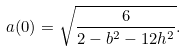Convert formula to latex. <formula><loc_0><loc_0><loc_500><loc_500>a ( 0 ) = \sqrt { \frac { 6 } { 2 - b ^ { 2 } - 1 2 h ^ { 2 } } } .</formula> 